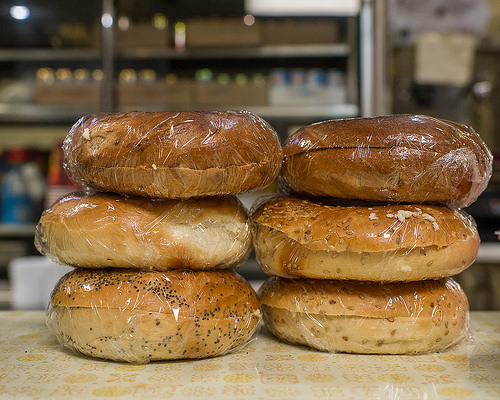<image>
Can you confirm if the bagel is under the shelf? No. The bagel is not positioned under the shelf. The vertical relationship between these objects is different. 